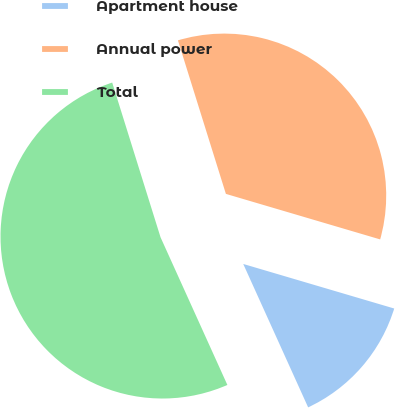Convert chart to OTSL. <chart><loc_0><loc_0><loc_500><loc_500><pie_chart><fcel>Apartment house<fcel>Annual power<fcel>Total<nl><fcel>13.67%<fcel>34.39%<fcel>51.95%<nl></chart> 